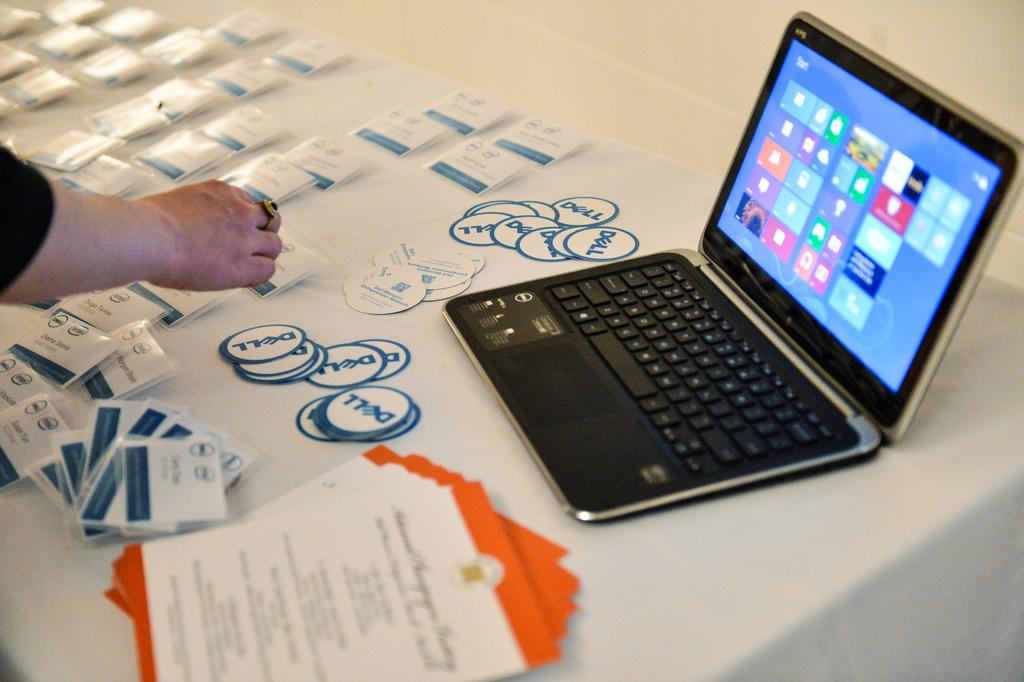Provide a one-sentence caption for the provided image. Dell is the company that is setting up for an event. 